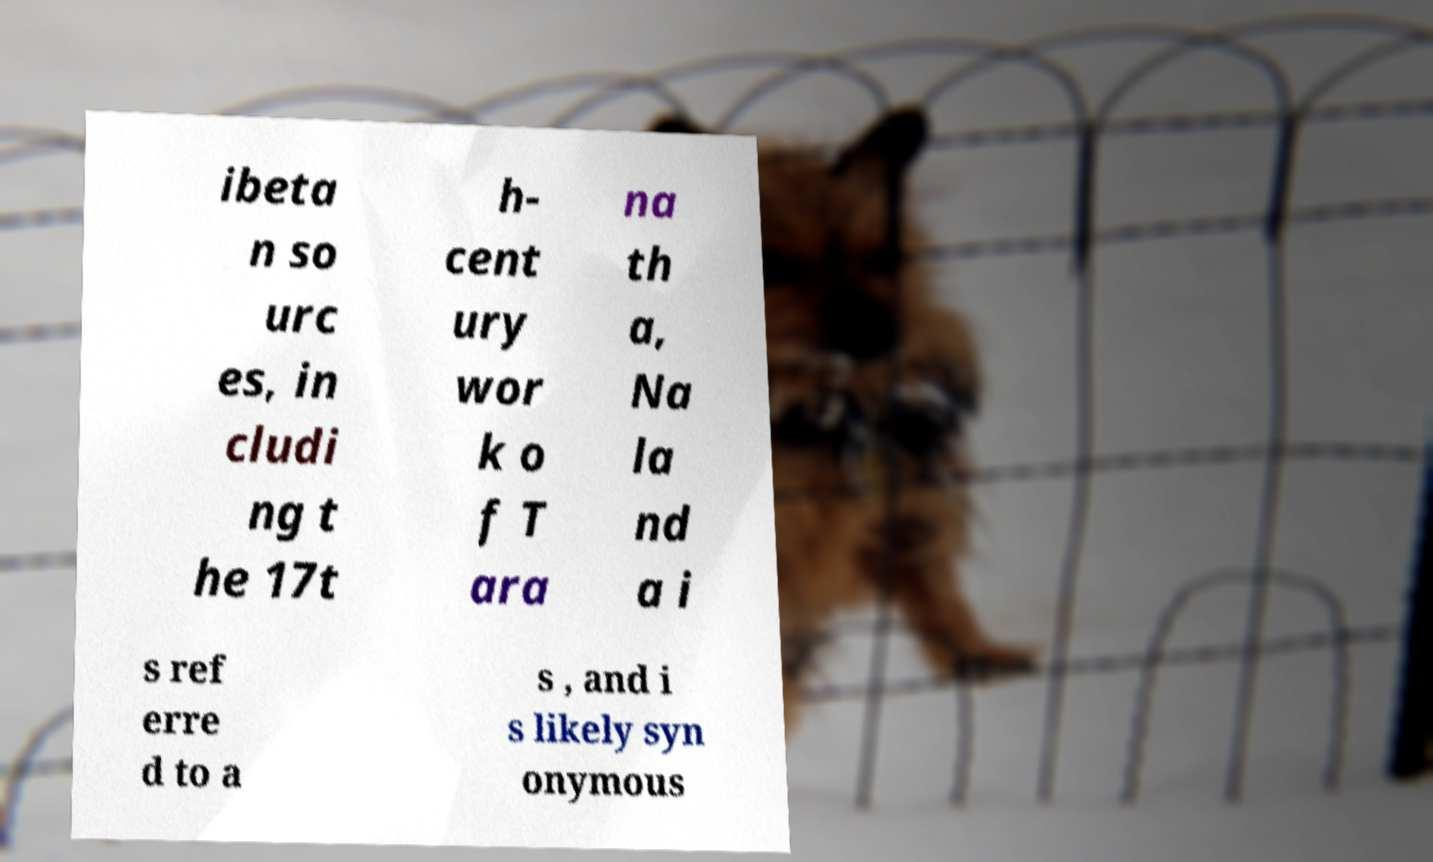Could you assist in decoding the text presented in this image and type it out clearly? ibeta n so urc es, in cludi ng t he 17t h- cent ury wor k o f T ara na th a, Na la nd a i s ref erre d to a s , and i s likely syn onymous 